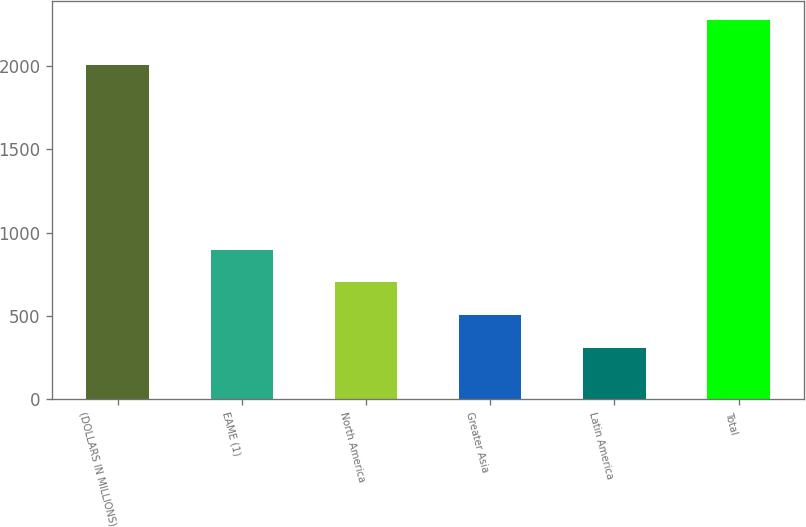Convert chart. <chart><loc_0><loc_0><loc_500><loc_500><bar_chart><fcel>(DOLLARS IN MILLIONS)<fcel>EAME (1)<fcel>North America<fcel>Greater Asia<fcel>Latin America<fcel>Total<nl><fcel>2007<fcel>897.3<fcel>700.2<fcel>503.1<fcel>306<fcel>2277<nl></chart> 